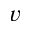<formula> <loc_0><loc_0><loc_500><loc_500>v</formula> 